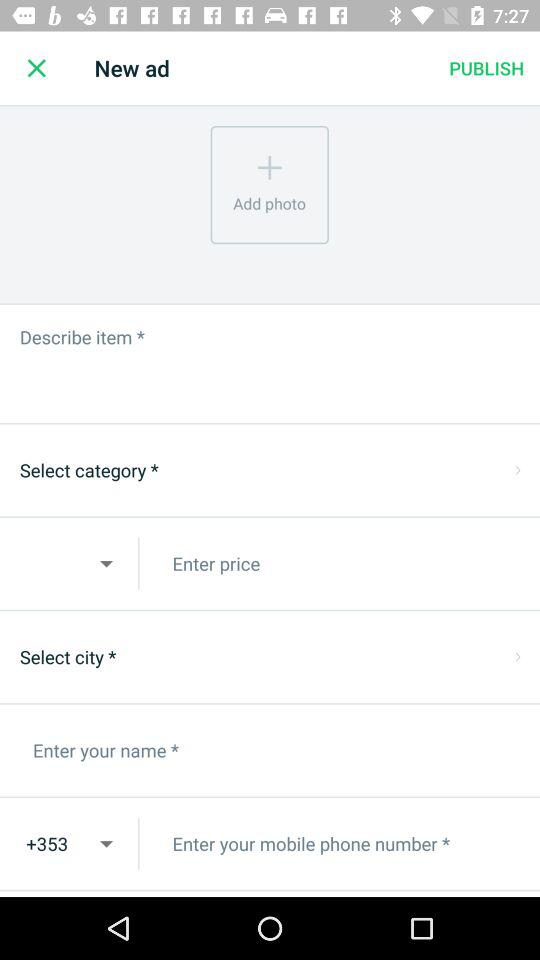What is the given country code? The given country code is +353. 